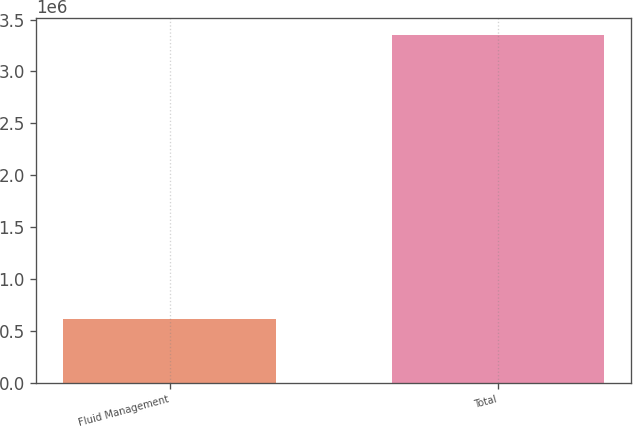Convert chart to OTSL. <chart><loc_0><loc_0><loc_500><loc_500><bar_chart><fcel>Fluid Management<fcel>Total<nl><fcel>617932<fcel>3.35022e+06<nl></chart> 